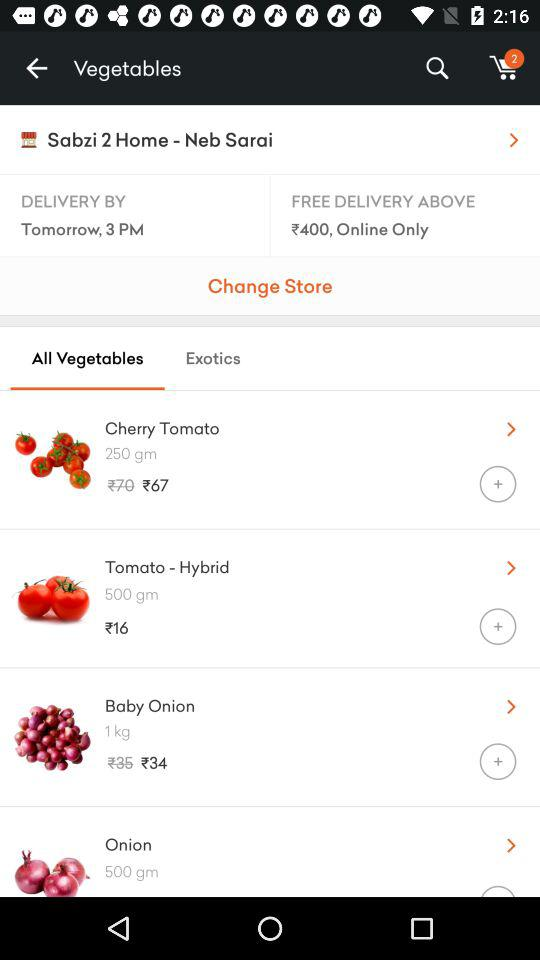What is the discounted price of "Baby Onion"? The discounted price of "Baby Onion" is ₹34. 